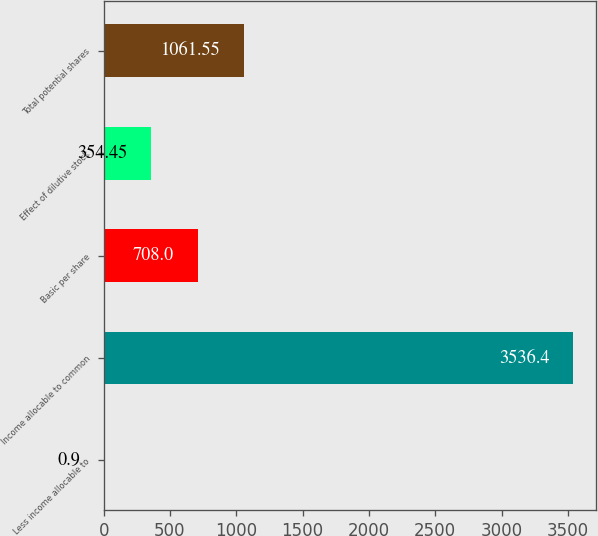<chart> <loc_0><loc_0><loc_500><loc_500><bar_chart><fcel>Less income allocable to<fcel>Income allocable to common<fcel>Basic per share<fcel>Effect of dilutive stock<fcel>Total potential shares<nl><fcel>0.9<fcel>3536.4<fcel>708<fcel>354.45<fcel>1061.55<nl></chart> 